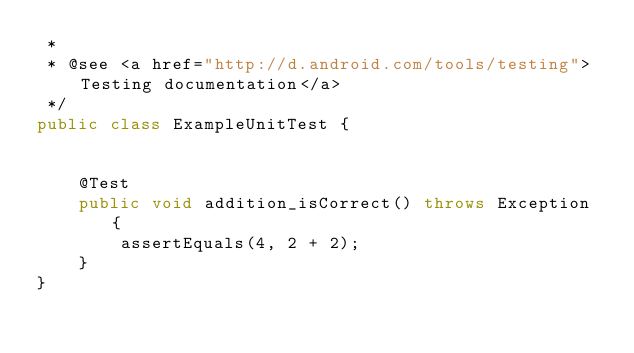<code> <loc_0><loc_0><loc_500><loc_500><_Java_> *
 * @see <a href="http://d.android.com/tools/testing">Testing documentation</a>
 */
public class ExampleUnitTest {


    @Test
    public void addition_isCorrect() throws Exception {
        assertEquals(4, 2 + 2);
    }
}</code> 